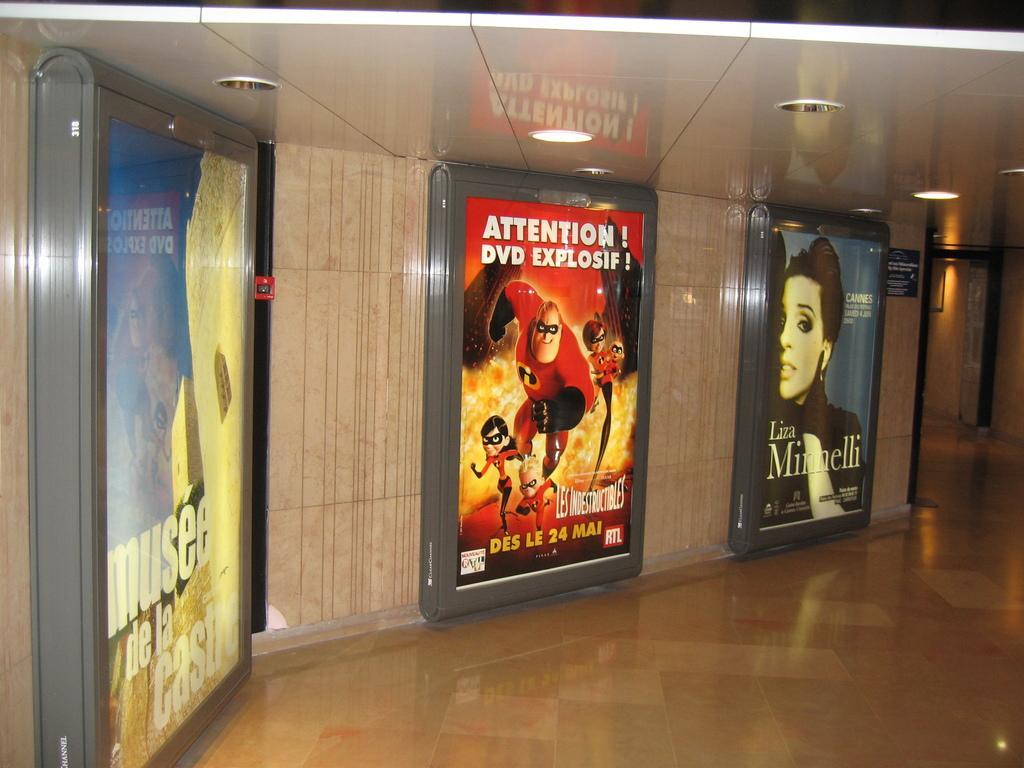Describe this image in one or two sentences. In this image we can see some posters on a wall with some pictures and text on it. We can also see the floor and a roof with some ceiling lights. 